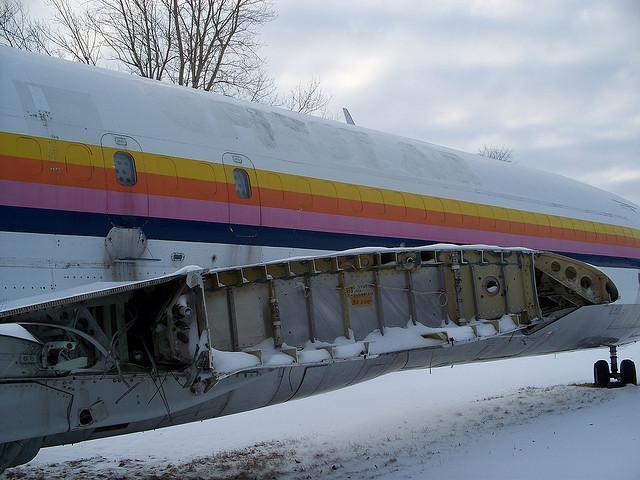How many different colors are on this plane?
Give a very brief answer. 5. How many vases glass vases are on the table?
Give a very brief answer. 0. 